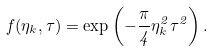Convert formula to latex. <formula><loc_0><loc_0><loc_500><loc_500>f ( \eta _ { k } , \tau ) = \exp \left ( - \frac { \pi } { 4 } \eta ^ { 2 } _ { k } \tau ^ { 2 } \right ) .</formula> 